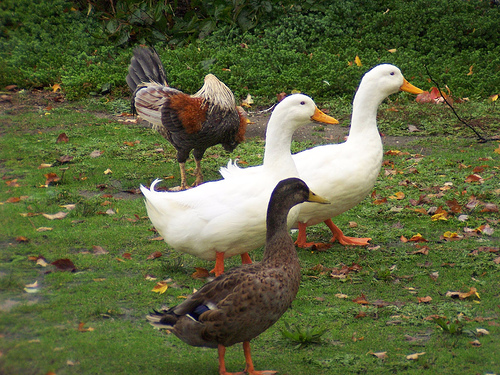<image>
Can you confirm if the duck is in front of the rooster? Yes. The duck is positioned in front of the rooster, appearing closer to the camera viewpoint. 